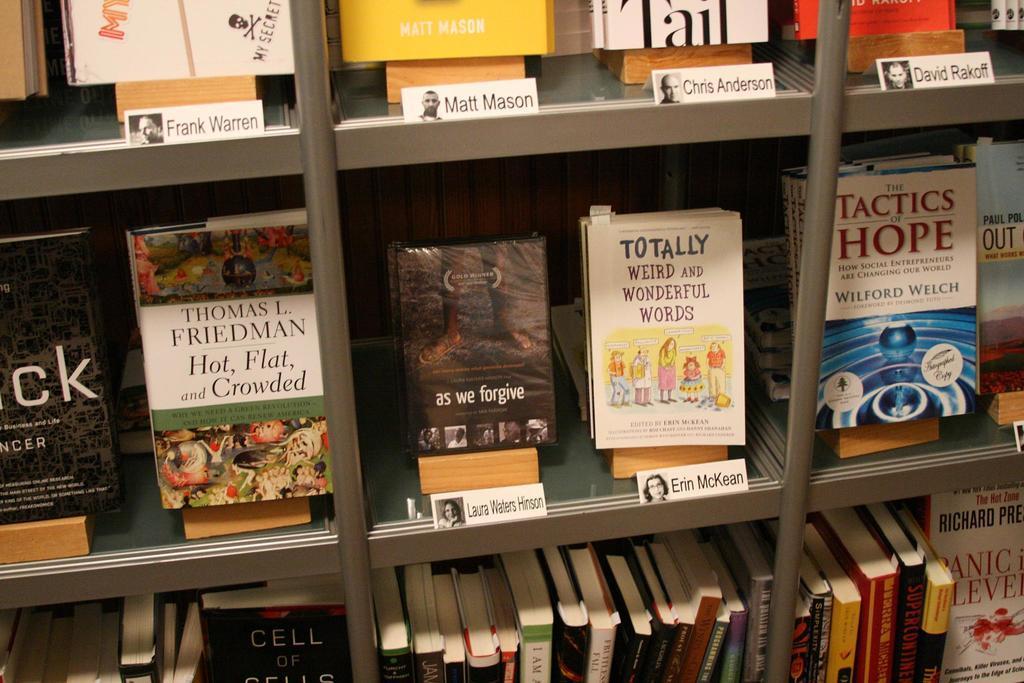Could you give a brief overview of what you see in this image? In the image there is a cupboard with many shelves. Inside the shelves there are books. And also there are white cards with names and images. 